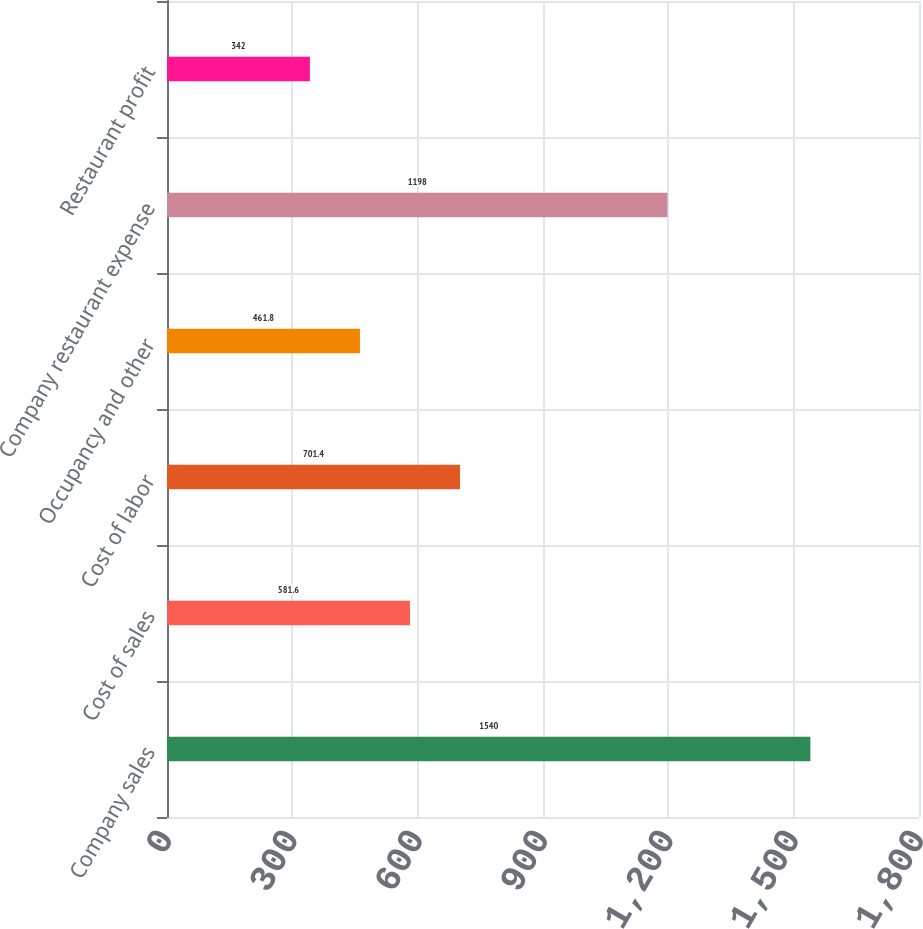Convert chart to OTSL. <chart><loc_0><loc_0><loc_500><loc_500><bar_chart><fcel>Company sales<fcel>Cost of sales<fcel>Cost of labor<fcel>Occupancy and other<fcel>Company restaurant expense<fcel>Restaurant profit<nl><fcel>1540<fcel>581.6<fcel>701.4<fcel>461.8<fcel>1198<fcel>342<nl></chart> 